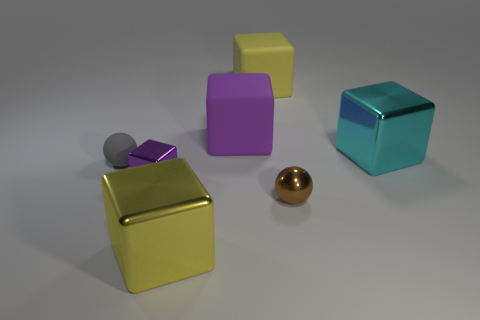How many yellow matte objects are behind the tiny brown shiny sphere?
Provide a short and direct response. 1. Are there the same number of large yellow cubes that are behind the small brown object and things?
Your answer should be compact. No. How many things are either small gray things or small cyan matte cylinders?
Your answer should be very brief. 1. There is a large yellow thing that is in front of the rubber object in front of the big purple object; what is its shape?
Keep it short and to the point. Cube. What shape is the tiny object that is made of the same material as the small cube?
Offer a very short reply. Sphere. There is a matte cube that is to the left of the big object that is behind the large purple matte object; what size is it?
Your answer should be very brief. Large. What is the shape of the yellow matte thing?
Your answer should be very brief. Cube. How many big objects are either purple metallic blocks or cyan spheres?
Your answer should be compact. 0. The gray object that is the same shape as the tiny brown metal thing is what size?
Give a very brief answer. Small. What number of metal things are both on the right side of the tiny purple metallic block and behind the large yellow metal object?
Your answer should be compact. 2. 